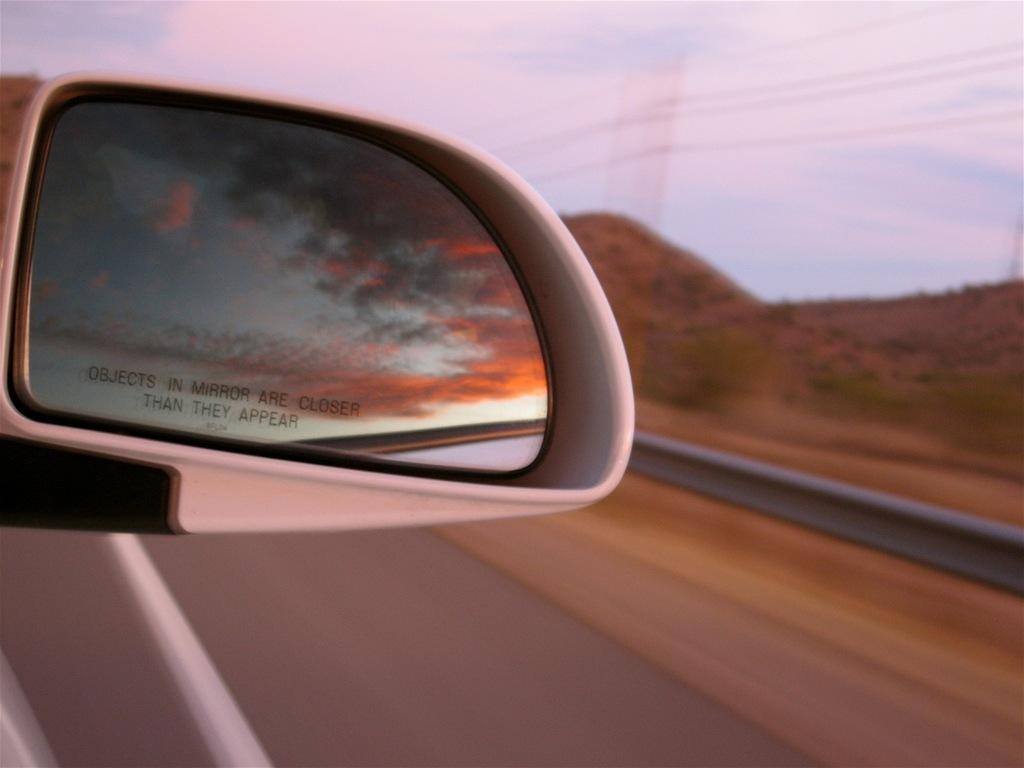What is the main subject of the image? The main subject of the image is a mirror of a vehicle. What is written or displayed on the vehicle's mirror? There is text on the vehicle's mirror. What can be seen on the right side of the image? There is a traffic barrier on the right side of the image. What type of natural landscape is visible in the image? Hills are visible in the image. What is visible in the background of the image? The sky is visible in the image. How many beads are hanging from the stick in the image? There is no stick or beads present in the image. What type of test is being conducted in the image? There is no test being conducted in the image. 